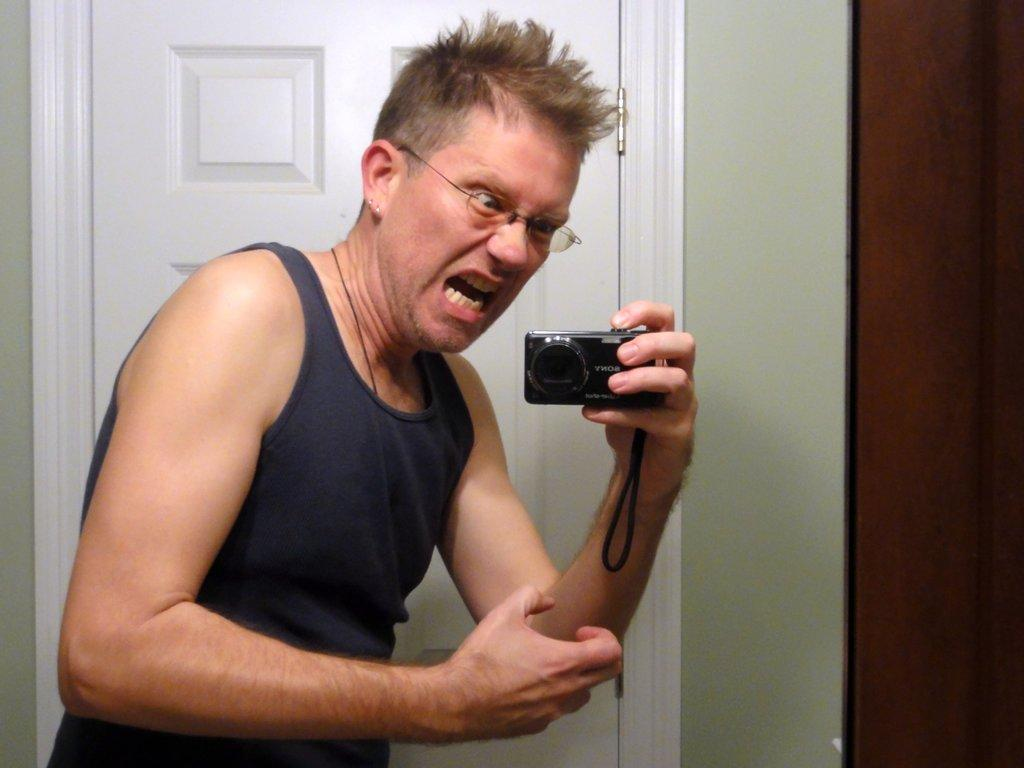Who is present in the image? There is a man in the image. What can be seen on the man's face? The man is wearing spectacles. What is the man holding in the image? The man is holding a camera. What can be seen in the background of the image? There is a white door in the background of the image. How many balloons are tied to the man's wrist in the image? There are no balloons present in the image. What type of bag is the man carrying in the image? The man is not carrying a bag in the image. 